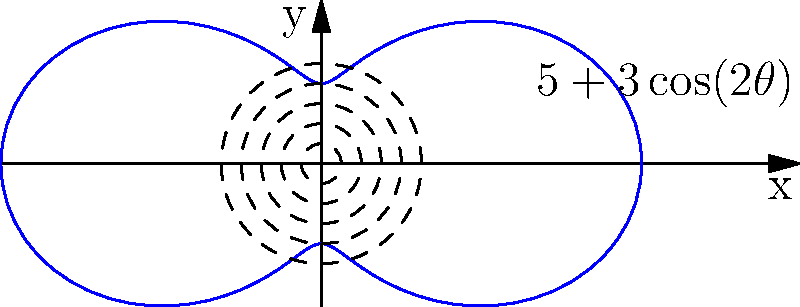A rotating crane at our construction site has a variable reach depending on its angle. The coverage area can be described by the polar equation $r = 5 + 3\cos(2\theta)$, where $r$ is in meters. What is the maximum reach of the crane, and at what angle(s) does this occur? To find the maximum reach of the crane and the angle(s) at which it occurs, we need to follow these steps:

1) The maximum reach will occur when $\cos(2\theta)$ is at its maximum value, which is 1.

2) When $\cos(2\theta) = 1$, the equation becomes:
   $r_{max} = 5 + 3(1) = 8$ meters

3) To find the angle(s) where this occurs, we need to solve:
   $\cos(2\theta) = 1$

4) This occurs when $2\theta = 0, 2\pi, 4\pi, ...$
   Or when $\theta = 0, \pi, 2\pi, ...$

5) In the context of a single rotation (0 to $2\pi$), this occurs at $\theta = 0$ and $\theta = \pi$.

6) Converting to degrees:
   $\theta = 0°$ and $\theta = 180°$

Therefore, the maximum reach of the crane is 8 meters, occurring at angles of 0° and 180°.
Answer: 8 meters at 0° and 180° 